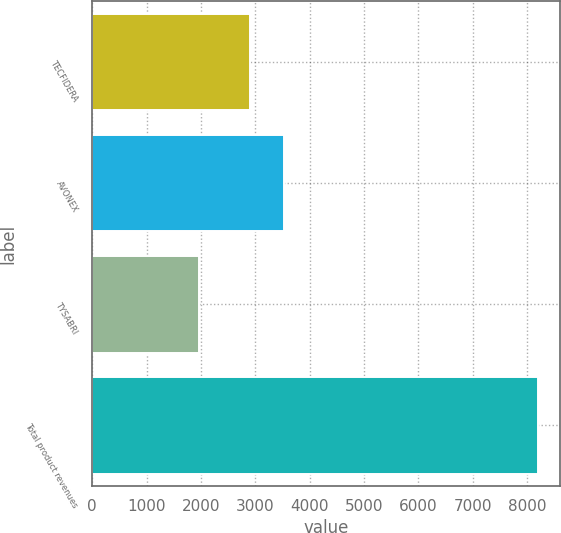Convert chart to OTSL. <chart><loc_0><loc_0><loc_500><loc_500><bar_chart><fcel>TECFIDERA<fcel>AVONEX<fcel>TYSABRI<fcel>Total product revenues<nl><fcel>2909.2<fcel>3533.59<fcel>1959.5<fcel>8203.4<nl></chart> 